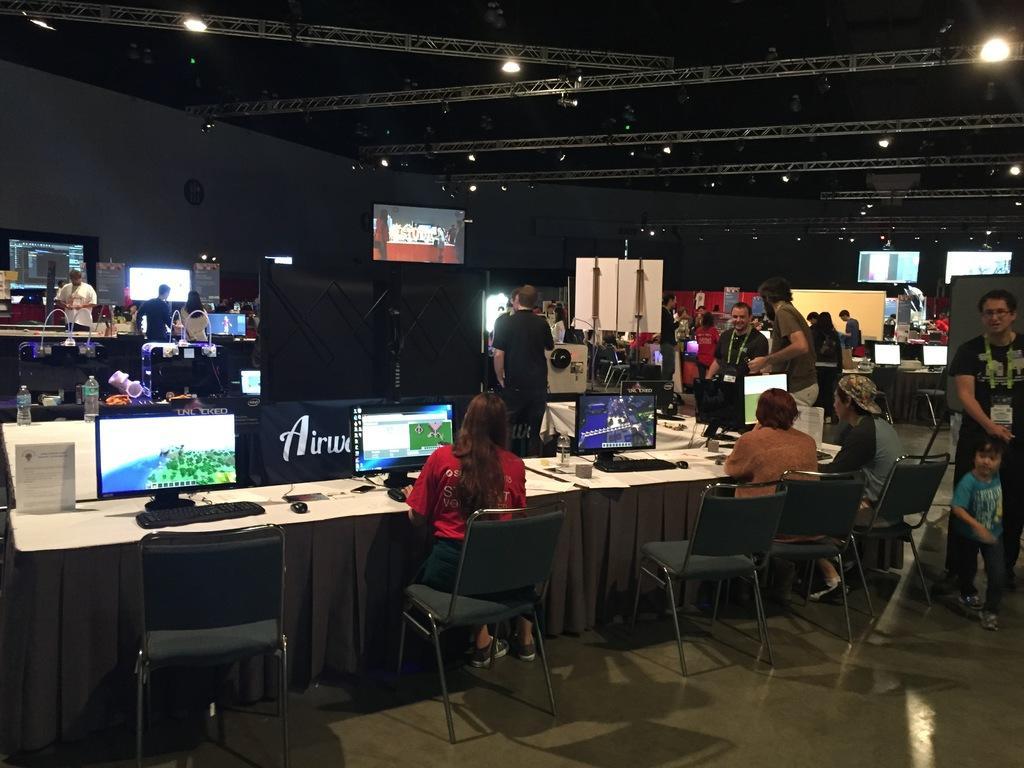How would you summarize this image in a sentence or two? In this image I see number of persons, in which few of them are sitting and rest of them are standing. I can also see there are number of screens, tables and the chairs. In the background I see the lights. 